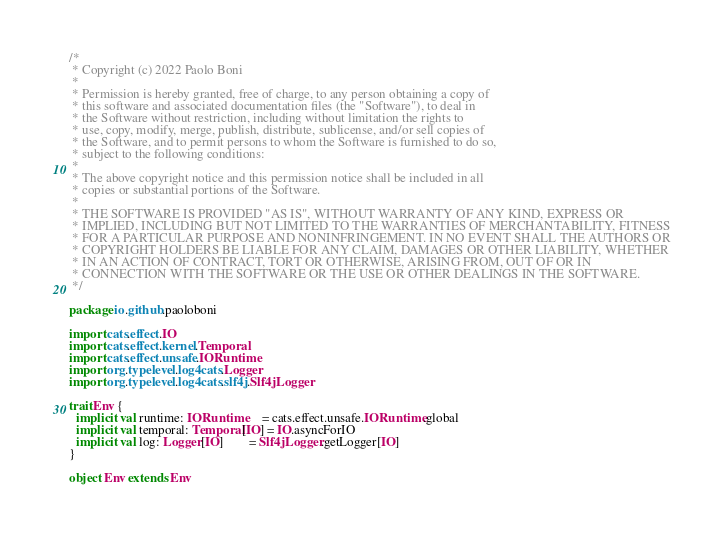<code> <loc_0><loc_0><loc_500><loc_500><_Scala_>/*
 * Copyright (c) 2022 Paolo Boni
 *
 * Permission is hereby granted, free of charge, to any person obtaining a copy of
 * this software and associated documentation files (the "Software"), to deal in
 * the Software without restriction, including without limitation the rights to
 * use, copy, modify, merge, publish, distribute, sublicense, and/or sell copies of
 * the Software, and to permit persons to whom the Software is furnished to do so,
 * subject to the following conditions:
 *
 * The above copyright notice and this permission notice shall be included in all
 * copies or substantial portions of the Software.
 *
 * THE SOFTWARE IS PROVIDED "AS IS", WITHOUT WARRANTY OF ANY KIND, EXPRESS OR
 * IMPLIED, INCLUDING BUT NOT LIMITED TO THE WARRANTIES OF MERCHANTABILITY, FITNESS
 * FOR A PARTICULAR PURPOSE AND NONINFRINGEMENT. IN NO EVENT SHALL THE AUTHORS OR
 * COPYRIGHT HOLDERS BE LIABLE FOR ANY CLAIM, DAMAGES OR OTHER LIABILITY, WHETHER
 * IN AN ACTION OF CONTRACT, TORT OR OTHERWISE, ARISING FROM, OUT OF OR IN
 * CONNECTION WITH THE SOFTWARE OR THE USE OR OTHER DEALINGS IN THE SOFTWARE.
 */

package io.github.paoloboni

import cats.effect.IO
import cats.effect.kernel.Temporal
import cats.effect.unsafe.IORuntime
import org.typelevel.log4cats.Logger
import org.typelevel.log4cats.slf4j.Slf4jLogger

trait Env {
  implicit val runtime: IORuntime     = cats.effect.unsafe.IORuntime.global
  implicit val temporal: Temporal[IO] = IO.asyncForIO
  implicit val log: Logger[IO]        = Slf4jLogger.getLogger[IO]
}

object Env extends Env
</code> 